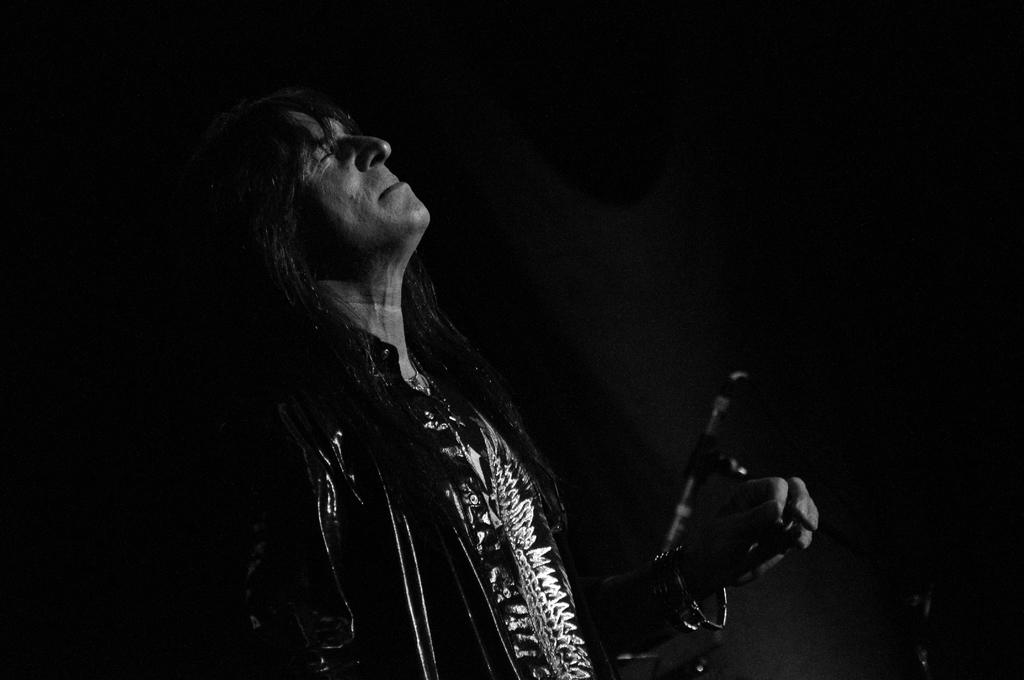What is the color scheme of the image? The image is black and white. Who or what can be seen in the image? There is a man standing in the image. What can be observed in the background of the image? The background of the image is dark, and there is a stand present. What type of corn is being used as a paste by the man in the image? There is no corn or paste present in the image; it features a man standing in a black and white setting with a dark background and a stand. 